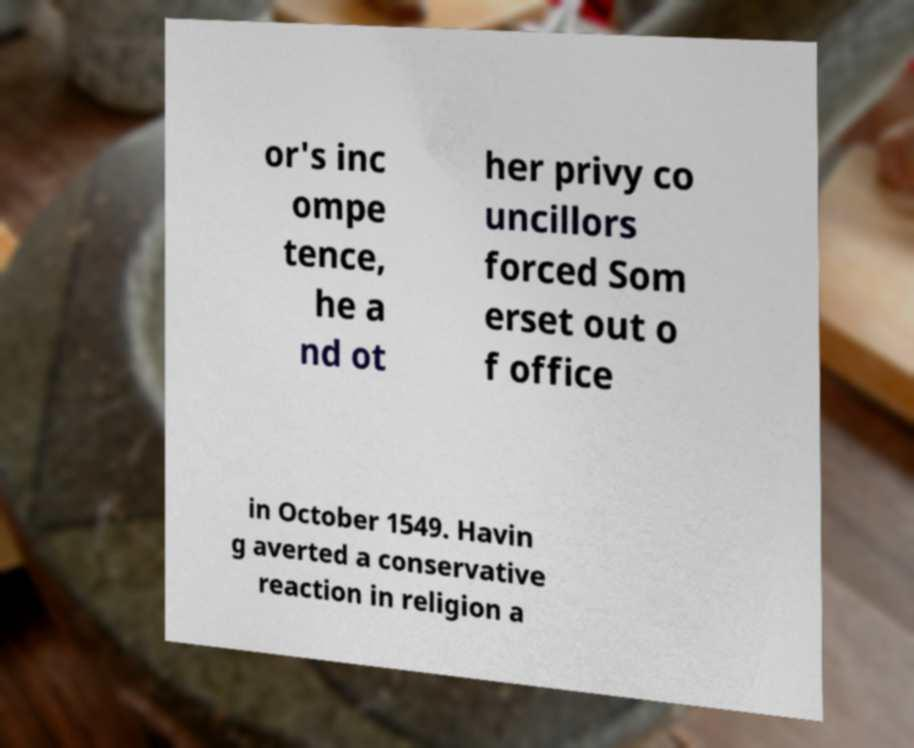Please read and relay the text visible in this image. What does it say? or's inc ompe tence, he a nd ot her privy co uncillors forced Som erset out o f office in October 1549. Havin g averted a conservative reaction in religion a 